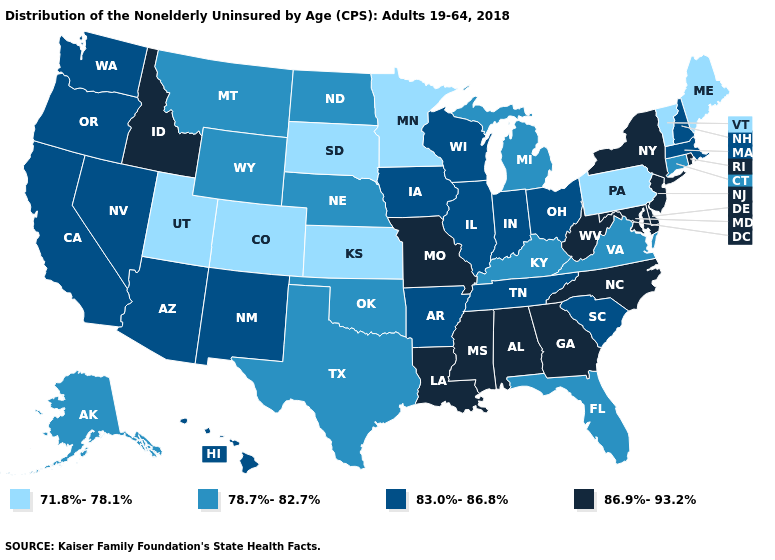Name the states that have a value in the range 83.0%-86.8%?
Be succinct. Arizona, Arkansas, California, Hawaii, Illinois, Indiana, Iowa, Massachusetts, Nevada, New Hampshire, New Mexico, Ohio, Oregon, South Carolina, Tennessee, Washington, Wisconsin. What is the lowest value in the MidWest?
Concise answer only. 71.8%-78.1%. Does Missouri have a lower value than Nevada?
Be succinct. No. What is the lowest value in the USA?
Quick response, please. 71.8%-78.1%. Which states have the lowest value in the USA?
Short answer required. Colorado, Kansas, Maine, Minnesota, Pennsylvania, South Dakota, Utah, Vermont. What is the value of Pennsylvania?
Keep it brief. 71.8%-78.1%. Does Minnesota have the highest value in the MidWest?
Write a very short answer. No. What is the value of New York?
Answer briefly. 86.9%-93.2%. What is the highest value in states that border Washington?
Short answer required. 86.9%-93.2%. What is the lowest value in the USA?
Short answer required. 71.8%-78.1%. What is the lowest value in the USA?
Write a very short answer. 71.8%-78.1%. Among the states that border New Mexico , which have the highest value?
Concise answer only. Arizona. Does the map have missing data?
Be succinct. No. Name the states that have a value in the range 71.8%-78.1%?
Keep it brief. Colorado, Kansas, Maine, Minnesota, Pennsylvania, South Dakota, Utah, Vermont. What is the highest value in states that border Mississippi?
Concise answer only. 86.9%-93.2%. 